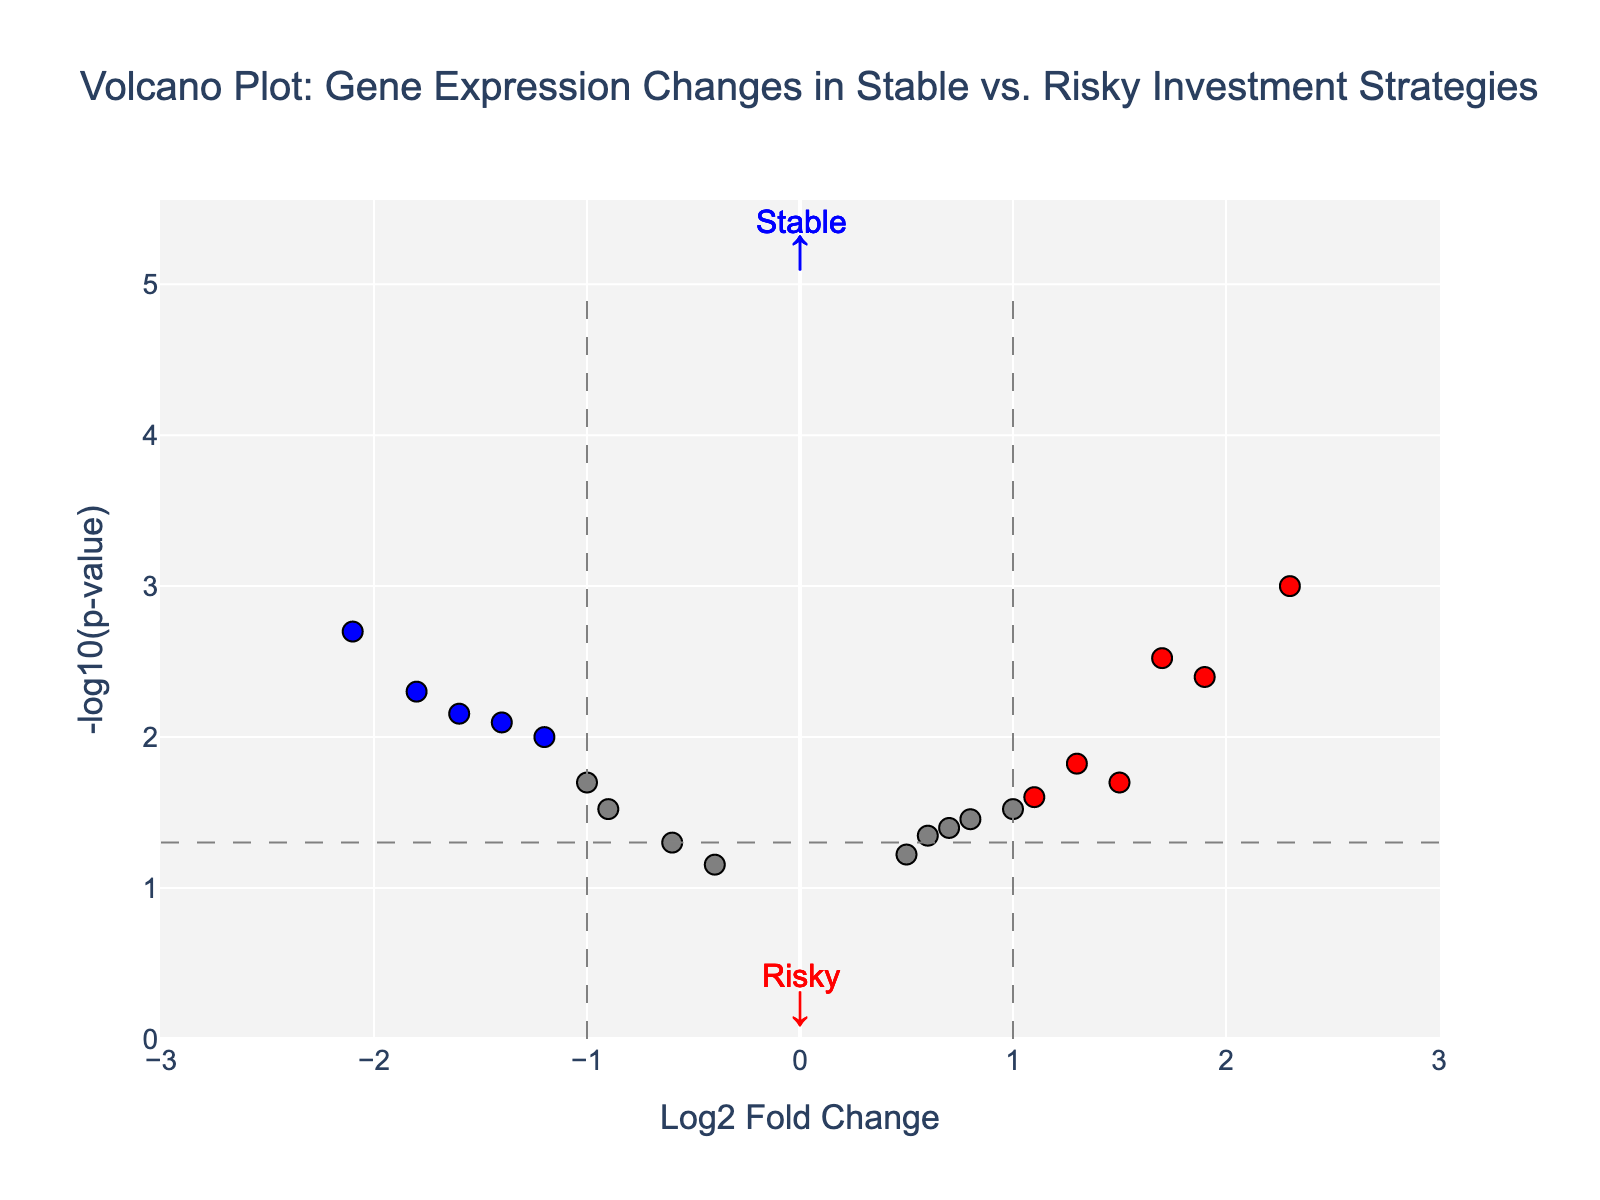What is the title of the plot? Look at the top of the plot, where the title is typically located, it says "Volcano Plot: Gene Expression Changes in Stable vs. Risky Investment Strategies"
Answer: Volcano Plot: Gene Expression Changes in Stable vs. Risky Investment Strategies Which axis shows the Log2 Fold Change? Notice the labels on axes. The horizontal axis is labeled "Log2 Fold Change" indicating it represents the Log2 Fold Change.
Answer: Horizontal axis How many genes are highlighted in red? Look at the data points on the plot and count those colored in red. These signify significant changes with a low p-value and high log2 fold change.
Answer: 6 What gene has the highest Log2 Fold Change? Identify the gene farthest to the right on the x-axis, indicating the highest positive log2 fold change. This is done by comparing positions.
Answer: HSPA1A Which gene has the lowest p-value? Look at the highest point on the y-axis. The higher the y value, the lower the p-value.
Answer: HSPA1A How many genes are labeled in the plot? Count the annotations directly labeling genes with significant changes based on colors and position. These summarize remarkable changes.
Answer: 10 What is the p-value threshold represented by a dashed horizontal line? A dashed horizontal line indicates the significance threshold for the p-value. Examine the annotations or the value of y-coordinate of the horizontal line. The threshold is the value which corresponds to -log10(p-value) = -log10(0.05).
Answer: 0.05 Which genes have a Log2 Fold Change less than -1 and are significant? Observe data points with log2 fold change below -1 and are colored to signify significance. Check the labels to identify specific genes.
Answer: IL6, CDKN1A, LEP How many genes show significant downregulation? Identify genes with negative Log2 Fold Change below threshold and p-values satisfying significance criteria - typically color-coded differently (e.g., blue). Count those data points.
Answer: 4 Would ADIPOQ be considered significant? Check the color-coding of the data points on the plot. Significant genes are usually marked with different colors (red or blue). ADIPOQ is colored, satisfying thresholds for significance.
Answer: Yes 